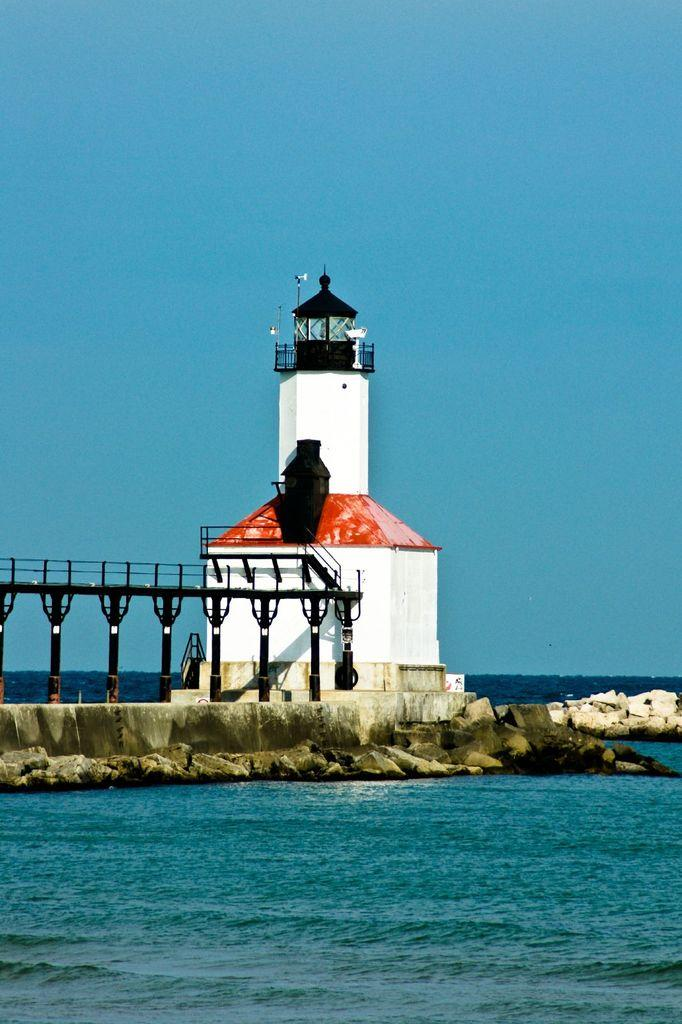What is the main feature of the image? The main feature of the image is water. What structure can be seen on the water? There is a bridge on the water in the image. What are the pillars in the image like? The pillars in the image are black. What other structure can be seen in the image? There is a white tower in the image. What color is the sky in the image? The sky is blue at the top of the image. What type of pets can be seen playing on the scale in the image? There are no pets or scales present in the image. What type of crime is being committed in the image? There is no crime being committed in the image; it features water, a bridge, black pillars, a white tower, and a blue sky. 